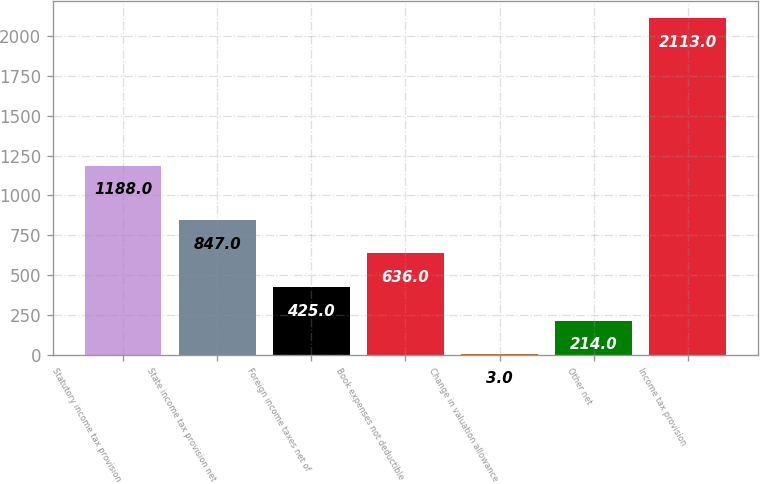<chart> <loc_0><loc_0><loc_500><loc_500><bar_chart><fcel>Statutory income tax provision<fcel>State income tax provision net<fcel>Foreign income taxes net of<fcel>Book expenses not deductible<fcel>Change in valuation allowance<fcel>Other net<fcel>Income tax provision<nl><fcel>1188<fcel>847<fcel>425<fcel>636<fcel>3<fcel>214<fcel>2113<nl></chart> 